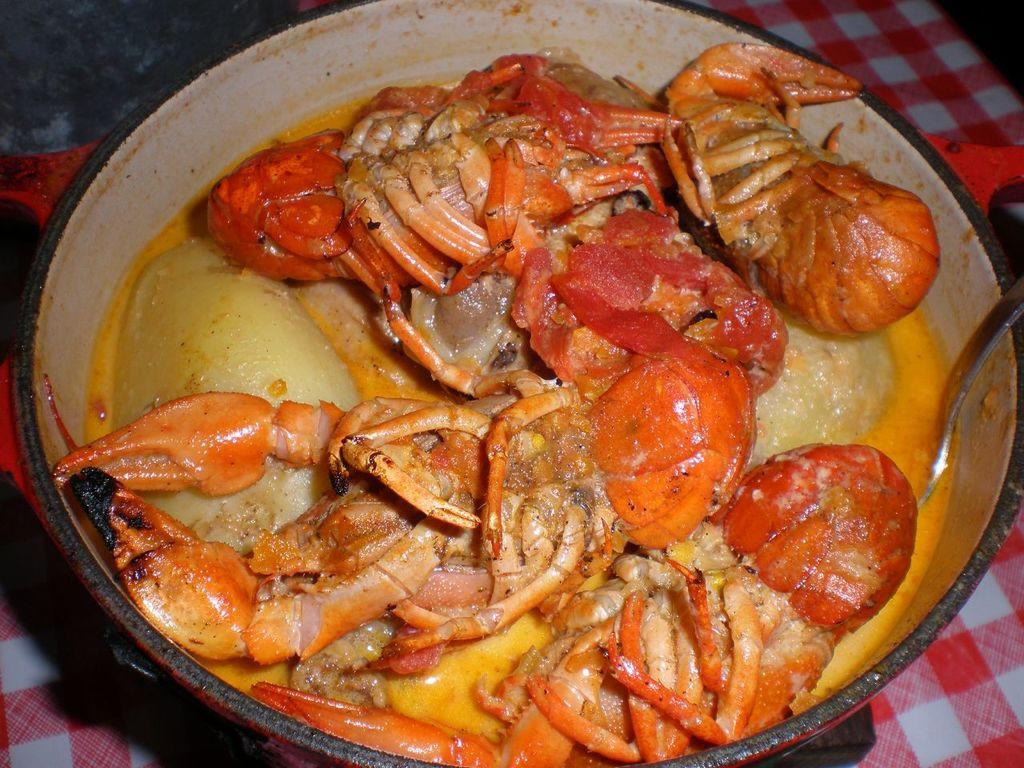What type of seafood is in the bowl in the image? There are crabs in a bowl in the image. What utensil is present in the bowl? There is a spoon in the bowl. What is the bowl placed on? The bowl is on a red and white color cloth. What type of mountain range can be seen in the background of the image? There is no mountain range visible in the image; it features a bowl of crabs with a spoon and a cloth. 